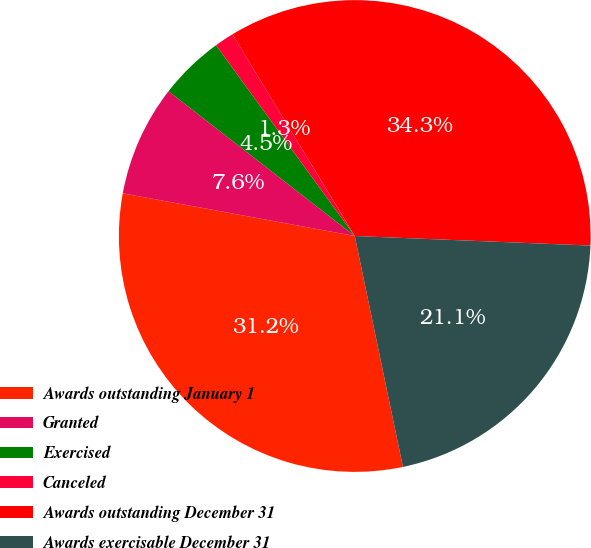<chart> <loc_0><loc_0><loc_500><loc_500><pie_chart><fcel>Awards outstanding January 1<fcel>Granted<fcel>Exercised<fcel>Canceled<fcel>Awards outstanding December 31<fcel>Awards exercisable December 31<nl><fcel>31.17%<fcel>7.62%<fcel>4.48%<fcel>1.33%<fcel>34.32%<fcel>21.08%<nl></chart> 